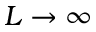<formula> <loc_0><loc_0><loc_500><loc_500>L \rightarrow \infty</formula> 